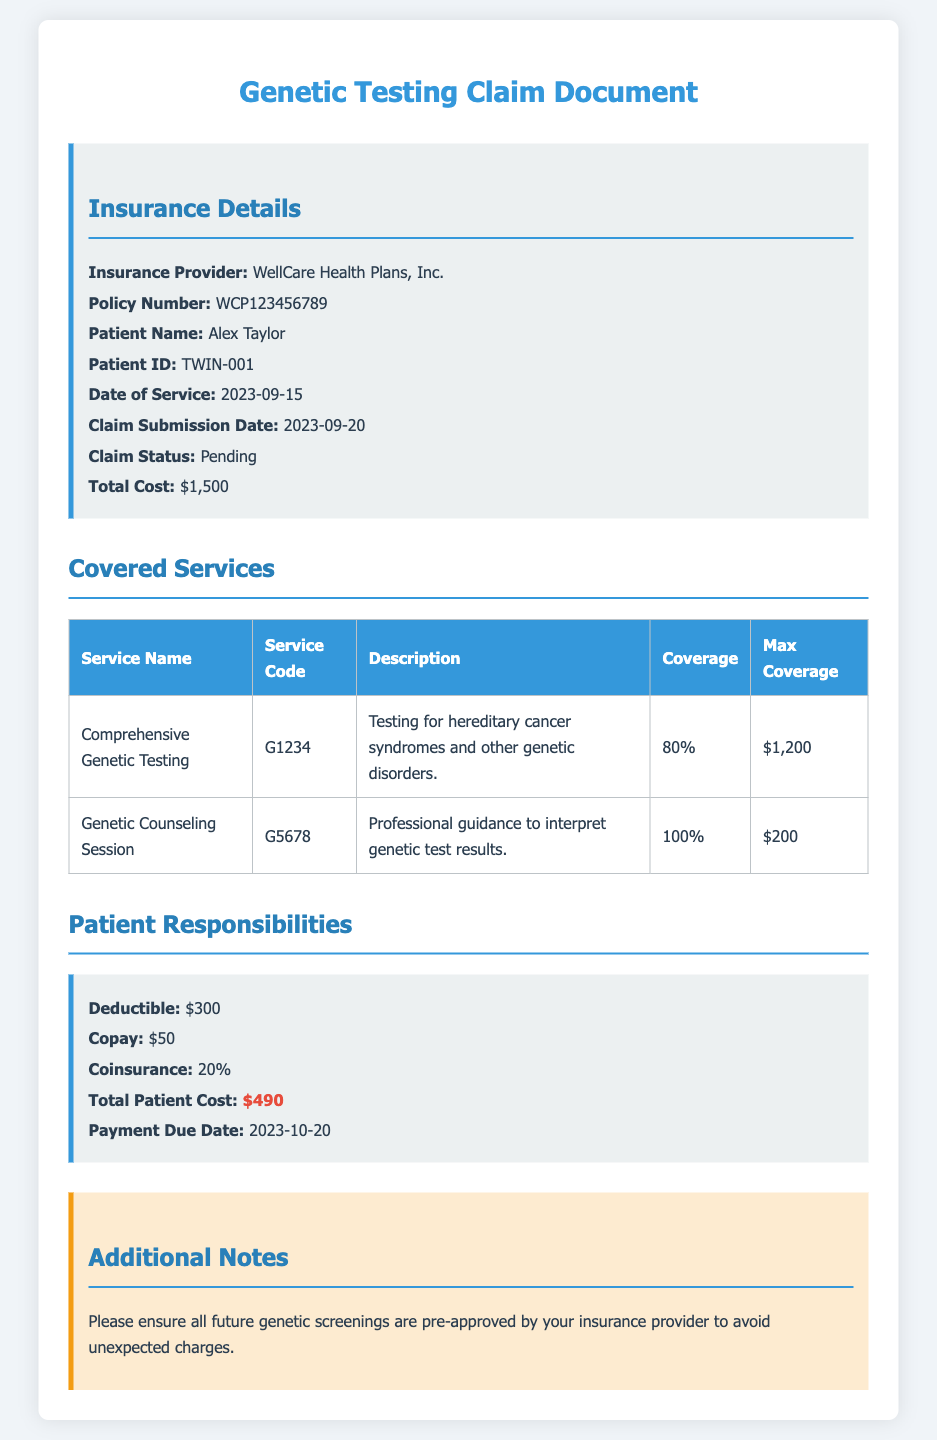What is the insurance provider? The insurance provider information is stated in the document under Insurance Details.
Answer: WellCare Health Plans, Inc What is the patient ID? The patient ID is provided under the patient information section in the document.
Answer: TWIN-001 What is the date of service? The date of service can be found in the Insurance Details section of the document.
Answer: 2023-09-15 What is the coverage percentage for Comprehensive Genetic Testing? The coverage percentage for this service is listed in the Covered Services table.
Answer: 80% What is the total patient cost? The total patient cost is summarized in the Patient Responsibilities section.
Answer: $490 How much is the deductible? The deductible amount is mentioned in the Patient Responsibilities section.
Answer: $300 What is the max coverage for Genetic Counseling Session? This information can be found in the Covered Services table under Max Coverage.
Answer: $200 What must be done for future genetic screenings? The additional notes section of the document indicates the requirement for future screenings.
Answer: Be pre-approved by your insurance provider What is the payment due date? The payment due date is listed in the Patient Responsibilities section of the document.
Answer: 2023-10-20 